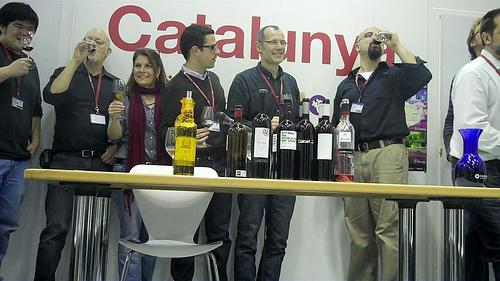What animal name does the first three letters on the wall spell?

Choices:
A) hen
B) pig
C) dog
D) cat cat 